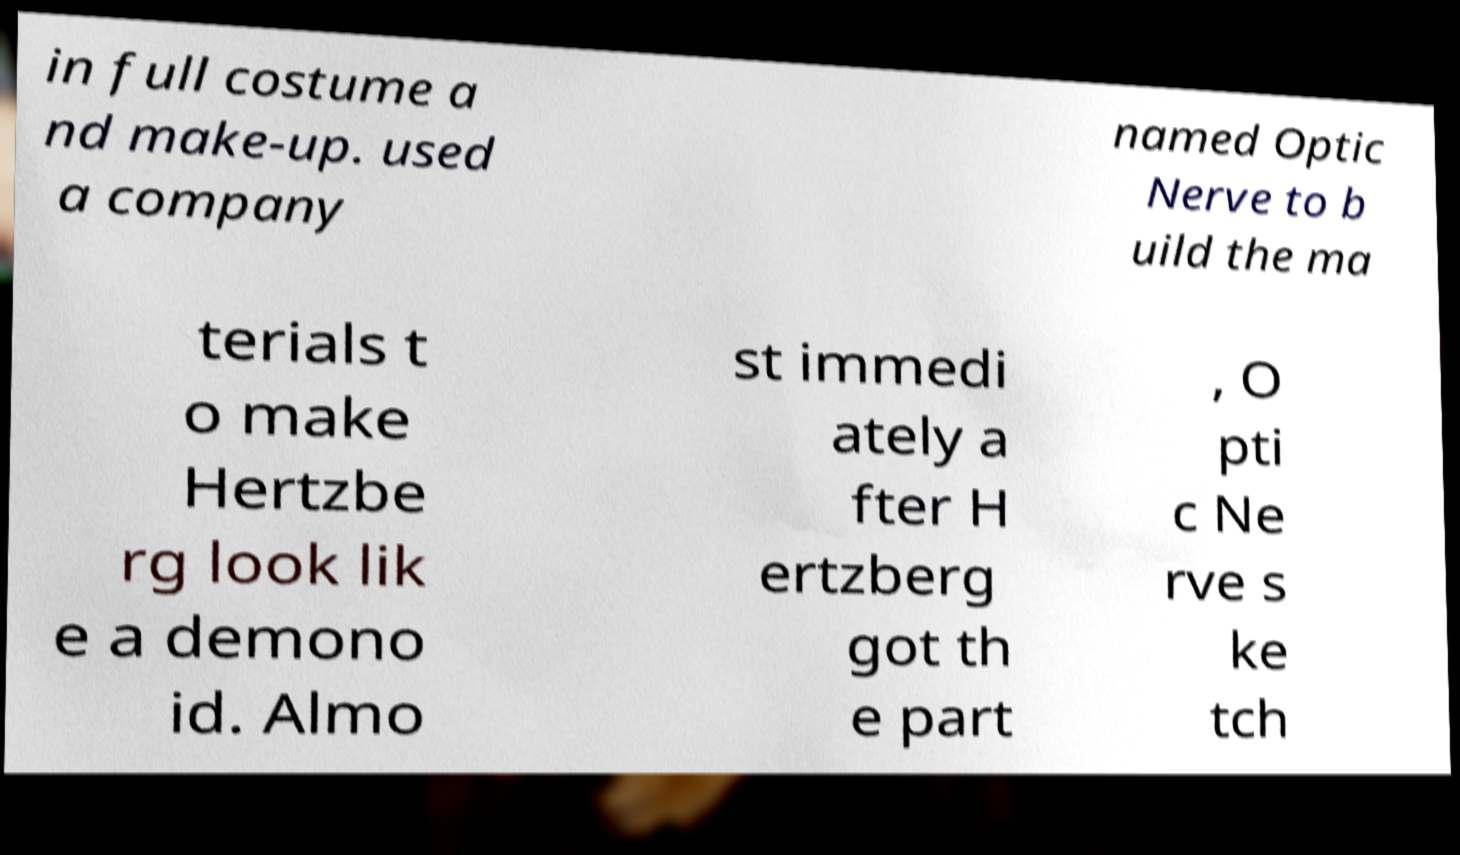Can you read and provide the text displayed in the image?This photo seems to have some interesting text. Can you extract and type it out for me? in full costume a nd make-up. used a company named Optic Nerve to b uild the ma terials t o make Hertzbe rg look lik e a demono id. Almo st immedi ately a fter H ertzberg got th e part , O pti c Ne rve s ke tch 